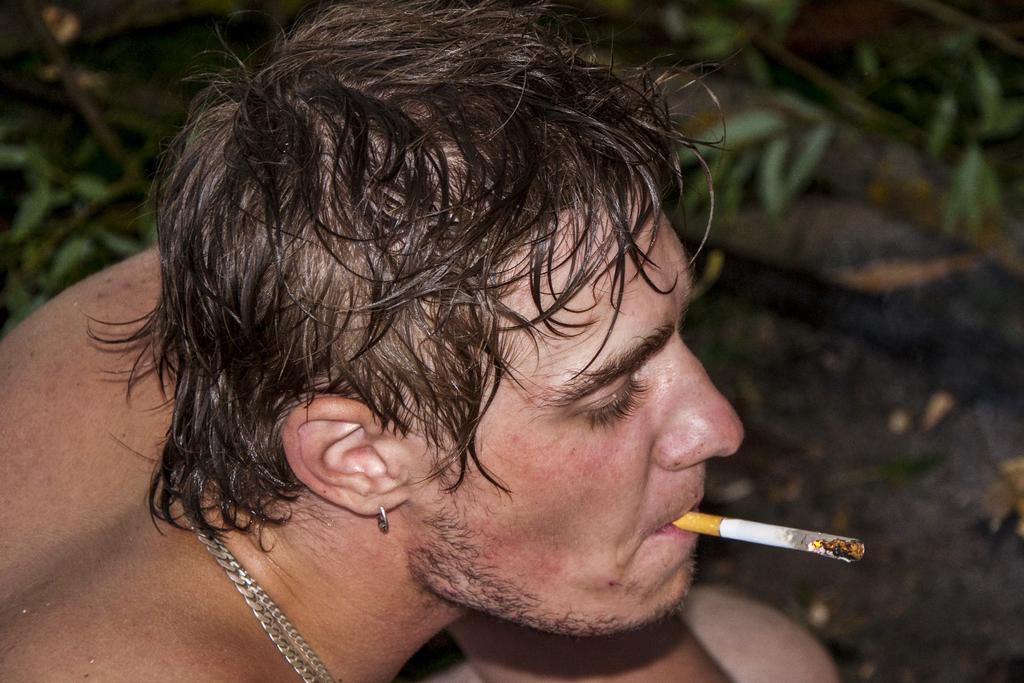Could you give a brief overview of what you see in this image? In this picture there is a man towards the left. In his mouth, there is a cigarette. In the background there are plants. 